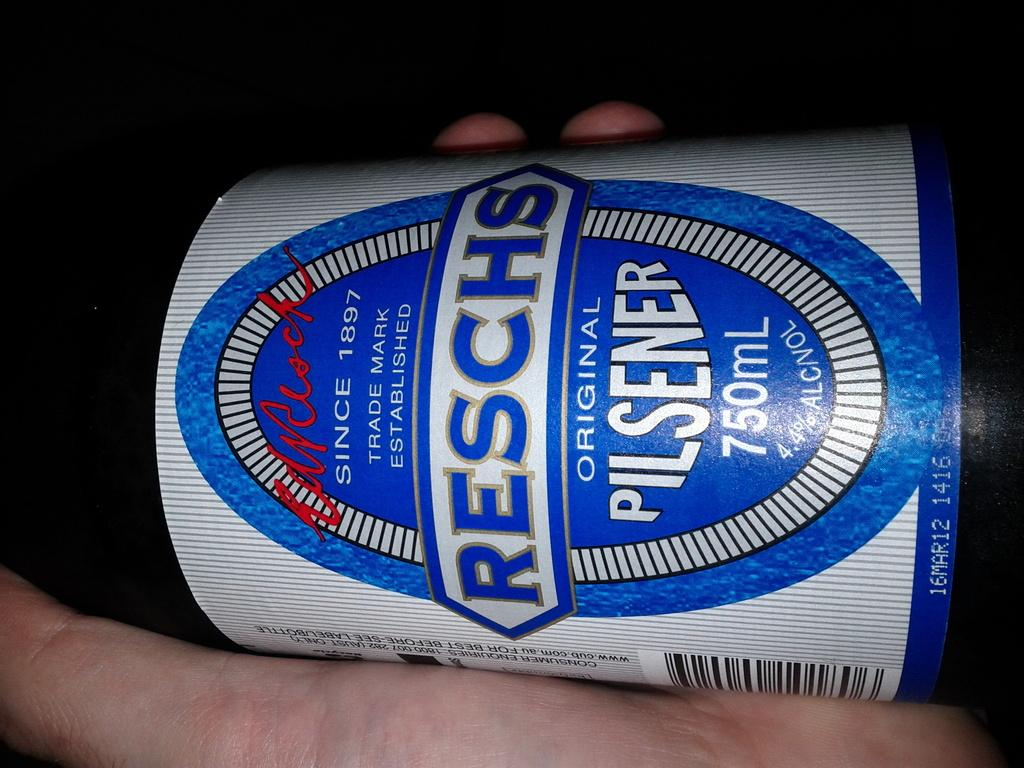<image>
Share a concise interpretation of the image provided. Reschs pilsner beer is being held in somebody's hand. 